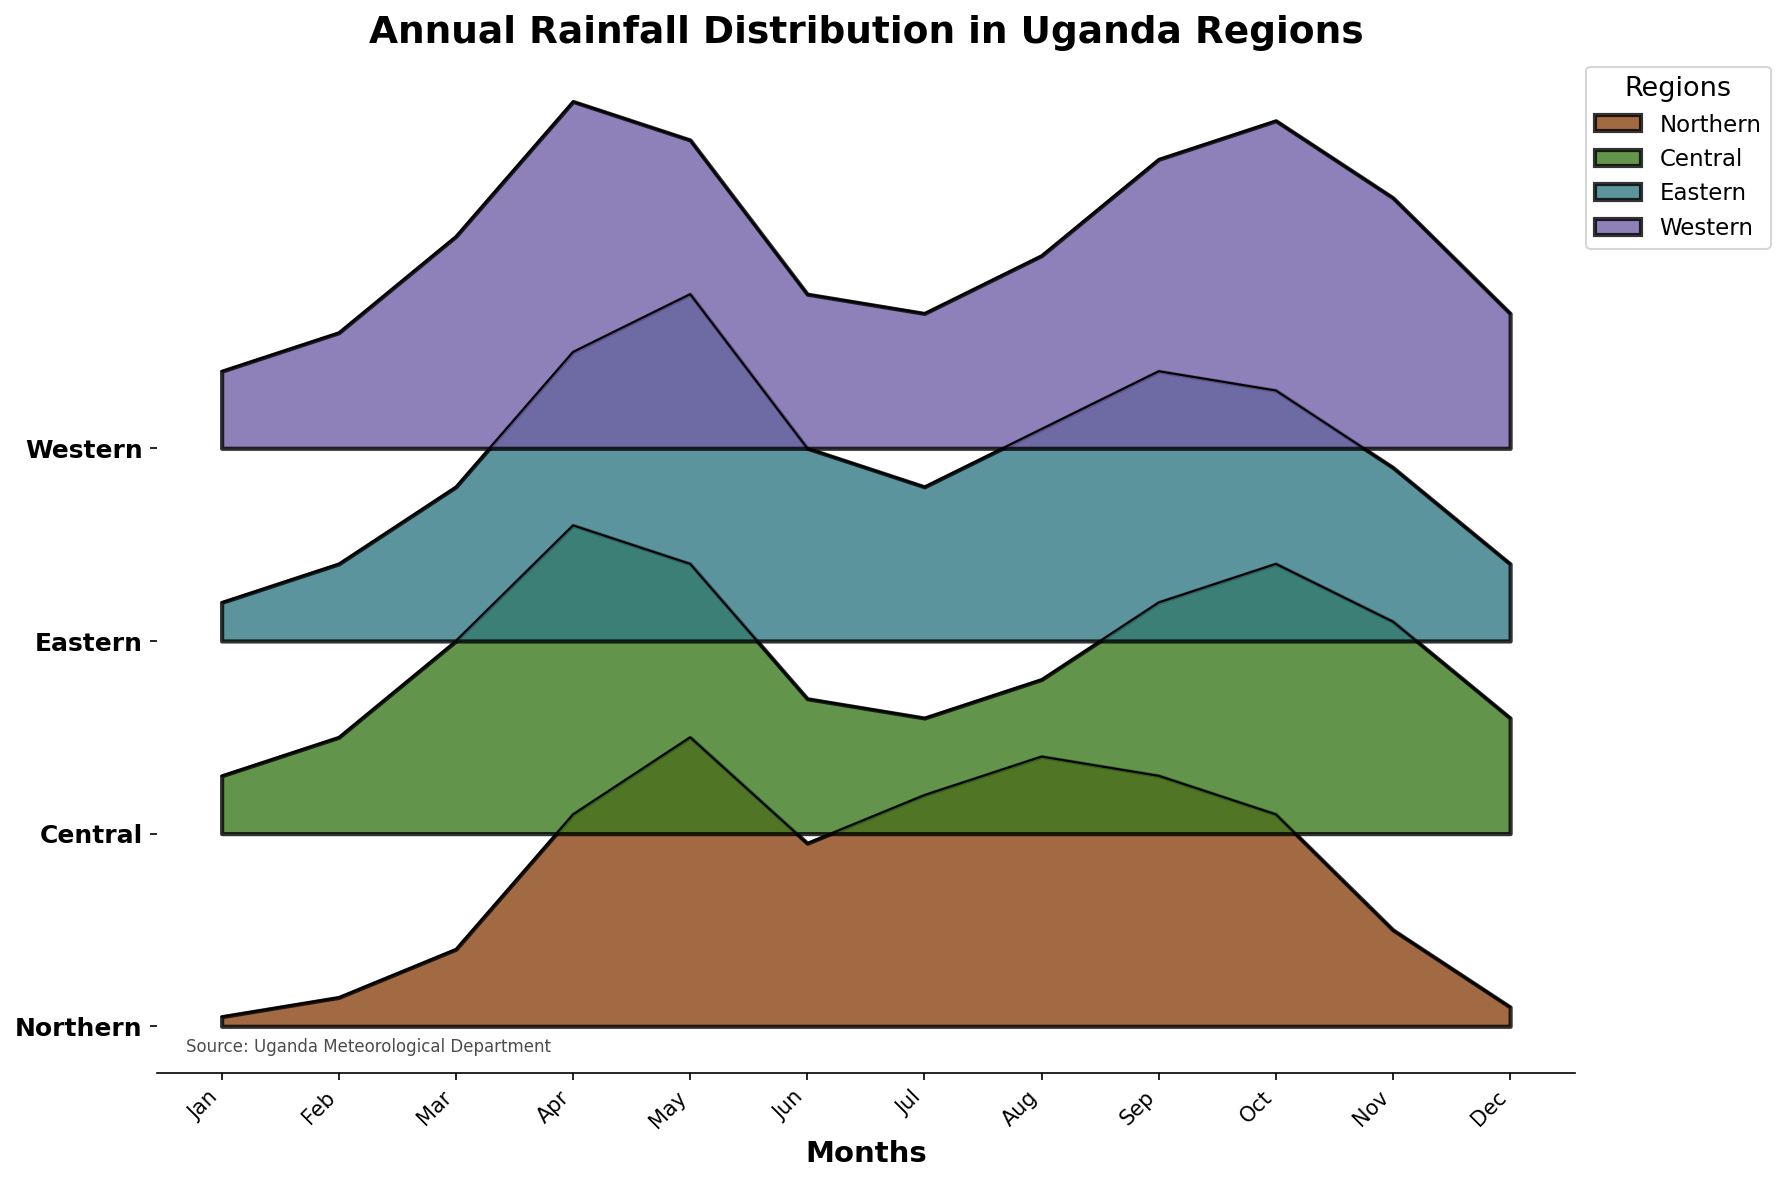What is the main title of the figure? The figure's main title is displayed prominently at the top, indicating the content and context of the visual data. The figure's main title is "Annual Rainfall Distribution in Uganda Regions".
Answer: Annual Rainfall Distribution in Uganda Regions Which region experiences the highest rainfall in April? To determine the region with the highest rainfall in April, observe the peaks in the April section of the plot for all regions and identify the highest one. The Western region shows the highest peak.
Answer: Western In which month does the Northern region experience the lowest rainfall, and what is the rate? Look at the ridgeline for the Northern region and identify the lowest point across all months. The lowest rainfall occurs in January, with a rate of 5 mm.
Answer: January, 5 mm How does the rainfall trend from January to December in the Central region? To understand the trend, follow the ridgeline of the Central region from January to December, observing the changes in rainfall levels. There is an initial rise from January, peaks around April and May, declines in mid-year, peaks again in October, and ends at a moderate level in December.
Answer: Rise, Peak, Decline, Peak, Moderate Which two regions experience very high rainfall in August? Look at the August section of the plot and identify which regions' ridgelines are categorized as Very High. The Northern and Eastern regions show Very High rainfall in August.
Answer: Northern, Eastern Compare the rainfall in May between the Western and Eastern regions. Which region has higher rainfall, and by how much? Observe the peaks for May in both Western and Eastern regions and compare their heights. The Western region has 160 mm, while the Eastern region has 180 mm, resulting in a difference of 20 mm.
Answer: Eastern, 20 mm In which months does the Northern region have high or very high rainfall? Track the ridge heights and categories of the Northern region across all months, noting the months where the rainfall is labeled as “High” or “Very High”. These months are April, May, June, July, August, September, and October.
Answer: April, May, June, July, August, September, October How many months does the Central region experience moderate rainfall? Count the number of months where the Central region’s rainfall is within the moderate category. It is moderate in February, June, July, and December.
Answer: 4 months What is the difference in rainfall between the driest month and wettest month in the Eastern region? Identify the lowest and highest points for the Eastern region and subtract the rainfall amount of the driest month from the wettest month. The driest month (January) has 20 mm, and the wettest month (May) has 180 mm, so the difference is 160 mm.
Answer: 160 mm During which month does the Western region’s rainfall exceed the Northern region’s rainfall by the largest margin? Compare the rainfall levels of both regions across all months and calculate the differences, identifying the month with the largest margin. In April, the Western region exceeds the Northern region by 70 mm (180 mm - 110 mm).
Answer: April 